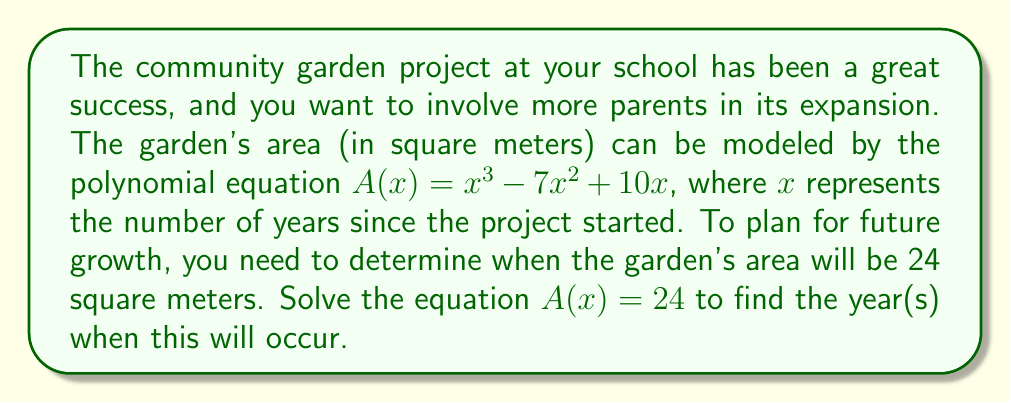Show me your answer to this math problem. Let's approach this step-by-step:

1) We start with the equation $A(x) = 24$, which expands to:
   $x^3 - 7x^2 + 10x = 24$

2) Rearrange the equation to standard form (all terms on one side, equal to zero):
   $x^3 - 7x^2 + 10x - 24 = 0$

3) This is a cubic equation. Let's try to factor it:
   First, factor out the greatest common factor (GCF):
   $x(x^2 - 7x + 10) - 24 = 0$

4) Now, let's try to factor the quadratic part $(x^2 - 7x + 10)$:
   The factors of 10 that add up to -7 are -2 and -5
   So, $x^2 - 7x + 10 = (x - 2)(x - 5)$

5) Our equation now looks like:
   $x(x - 2)(x - 5) - 24 = 0$

6) Factor by grouping:
   $x(x - 2)(x - 5) - 24 = 0$
   $(x - 2)[x(x - 5) - 12] = 0$
   $(x - 2)(x^2 - 5x - 12) = 0$
   $(x - 2)(x - 6)(x + 1) = 0$

7) Use the zero product property. The solutions are the values of x that make any factor equal to zero:
   $x - 2 = 0$ or $x - 6 = 0$ or $x + 1 = 0$
   $x = 2$ or $x = 6$ or $x = -1$

8) Since $x$ represents years since the project started, we can discard the negative solution.

Therefore, the garden will be 24 square meters after 2 years and 6 years from the start of the project.
Answer: The garden will have an area of 24 square meters after 2 years and 6 years from the start of the project. 